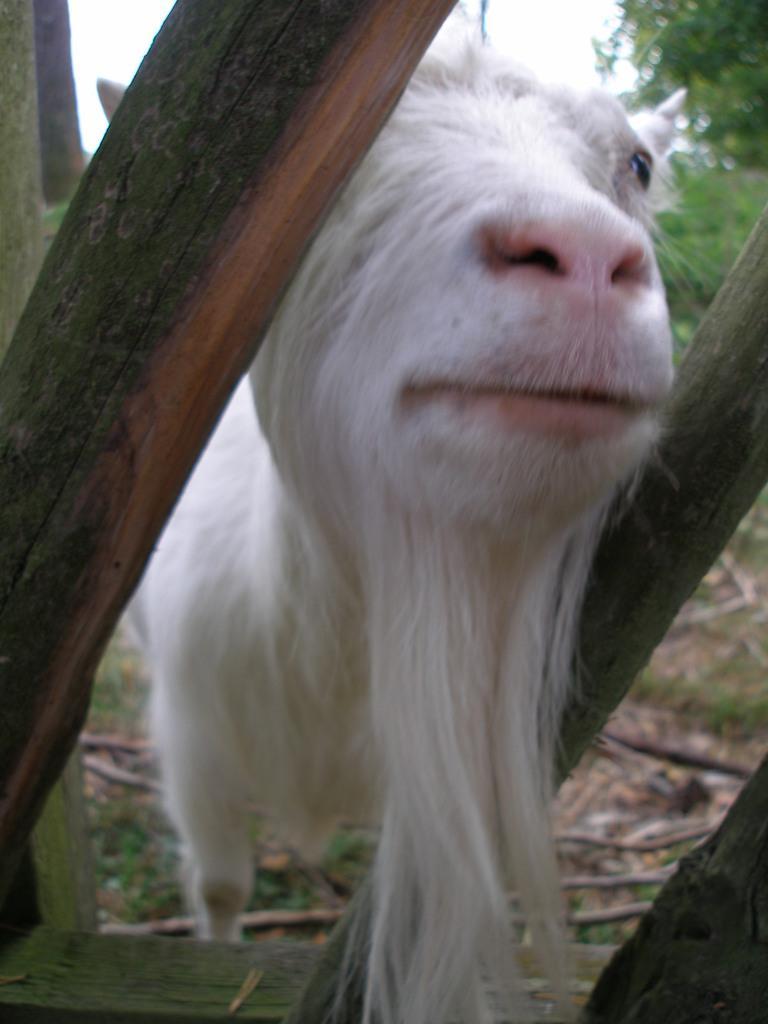In one or two sentences, can you explain what this image depicts? In this picture there is an animal standing behind the wooden railing. At the back there is a tree. At the top there is sky. At the bottom there is grass and there are sticks. 